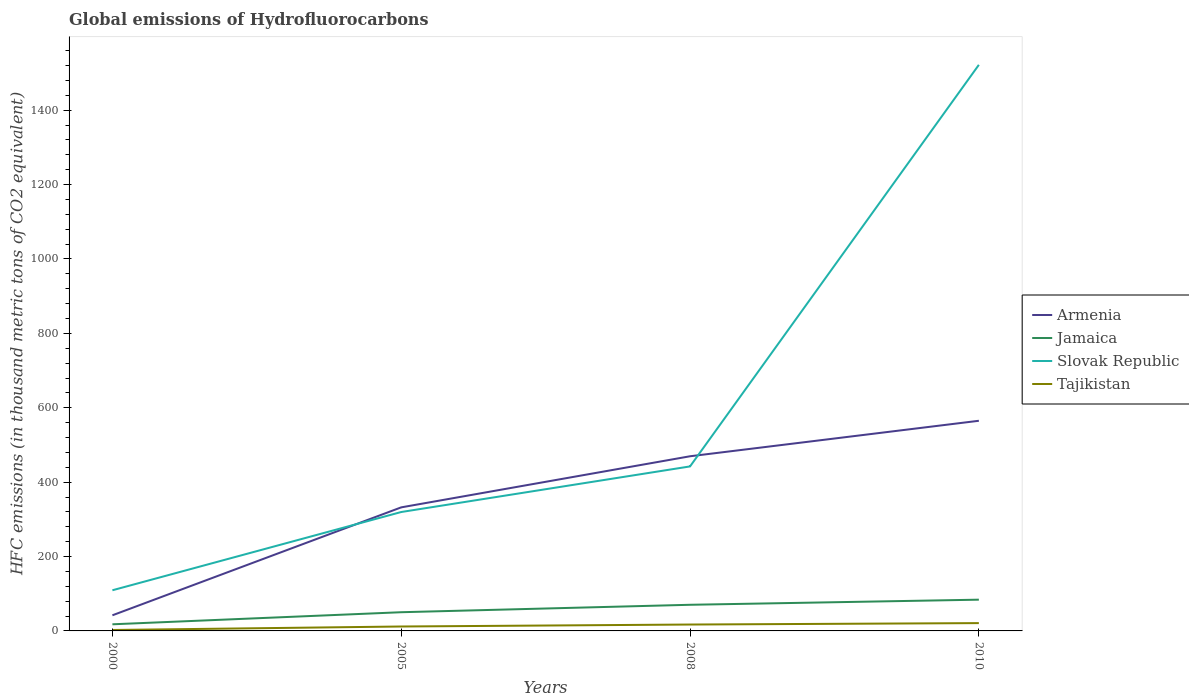How many different coloured lines are there?
Your response must be concise. 4. Does the line corresponding to Armenia intersect with the line corresponding to Jamaica?
Offer a very short reply. No. In which year was the global emissions of Hydrofluorocarbons in Armenia maximum?
Your answer should be compact. 2000. What is the total global emissions of Hydrofluorocarbons in Slovak Republic in the graph?
Ensure brevity in your answer.  -1412.7. What is the difference between the highest and the second highest global emissions of Hydrofluorocarbons in Slovak Republic?
Offer a terse response. 1412.7. What is the difference between the highest and the lowest global emissions of Hydrofluorocarbons in Jamaica?
Provide a succinct answer. 2. Is the global emissions of Hydrofluorocarbons in Armenia strictly greater than the global emissions of Hydrofluorocarbons in Jamaica over the years?
Make the answer very short. No. How many lines are there?
Make the answer very short. 4. How many years are there in the graph?
Your answer should be very brief. 4. Are the values on the major ticks of Y-axis written in scientific E-notation?
Make the answer very short. No. Does the graph contain any zero values?
Provide a short and direct response. No. What is the title of the graph?
Keep it short and to the point. Global emissions of Hydrofluorocarbons. What is the label or title of the X-axis?
Offer a terse response. Years. What is the label or title of the Y-axis?
Give a very brief answer. HFC emissions (in thousand metric tons of CO2 equivalent). What is the HFC emissions (in thousand metric tons of CO2 equivalent) in Armenia in 2000?
Give a very brief answer. 42. What is the HFC emissions (in thousand metric tons of CO2 equivalent) of Slovak Republic in 2000?
Offer a very short reply. 109.3. What is the HFC emissions (in thousand metric tons of CO2 equivalent) of Tajikistan in 2000?
Offer a very short reply. 2.5. What is the HFC emissions (in thousand metric tons of CO2 equivalent) in Armenia in 2005?
Offer a very short reply. 332.2. What is the HFC emissions (in thousand metric tons of CO2 equivalent) in Jamaica in 2005?
Give a very brief answer. 50.3. What is the HFC emissions (in thousand metric tons of CO2 equivalent) of Slovak Republic in 2005?
Your answer should be very brief. 319.7. What is the HFC emissions (in thousand metric tons of CO2 equivalent) in Armenia in 2008?
Offer a very short reply. 469.6. What is the HFC emissions (in thousand metric tons of CO2 equivalent) in Jamaica in 2008?
Ensure brevity in your answer.  70.3. What is the HFC emissions (in thousand metric tons of CO2 equivalent) in Slovak Republic in 2008?
Offer a terse response. 442.3. What is the HFC emissions (in thousand metric tons of CO2 equivalent) of Tajikistan in 2008?
Give a very brief answer. 17.2. What is the HFC emissions (in thousand metric tons of CO2 equivalent) in Armenia in 2010?
Offer a very short reply. 565. What is the HFC emissions (in thousand metric tons of CO2 equivalent) in Jamaica in 2010?
Ensure brevity in your answer.  84. What is the HFC emissions (in thousand metric tons of CO2 equivalent) in Slovak Republic in 2010?
Keep it short and to the point. 1522. Across all years, what is the maximum HFC emissions (in thousand metric tons of CO2 equivalent) of Armenia?
Your answer should be compact. 565. Across all years, what is the maximum HFC emissions (in thousand metric tons of CO2 equivalent) of Slovak Republic?
Keep it short and to the point. 1522. Across all years, what is the maximum HFC emissions (in thousand metric tons of CO2 equivalent) in Tajikistan?
Your answer should be compact. 21. Across all years, what is the minimum HFC emissions (in thousand metric tons of CO2 equivalent) in Armenia?
Keep it short and to the point. 42. Across all years, what is the minimum HFC emissions (in thousand metric tons of CO2 equivalent) of Jamaica?
Provide a short and direct response. 17.8. Across all years, what is the minimum HFC emissions (in thousand metric tons of CO2 equivalent) in Slovak Republic?
Keep it short and to the point. 109.3. What is the total HFC emissions (in thousand metric tons of CO2 equivalent) in Armenia in the graph?
Ensure brevity in your answer.  1408.8. What is the total HFC emissions (in thousand metric tons of CO2 equivalent) of Jamaica in the graph?
Offer a terse response. 222.4. What is the total HFC emissions (in thousand metric tons of CO2 equivalent) in Slovak Republic in the graph?
Keep it short and to the point. 2393.3. What is the total HFC emissions (in thousand metric tons of CO2 equivalent) in Tajikistan in the graph?
Give a very brief answer. 52.6. What is the difference between the HFC emissions (in thousand metric tons of CO2 equivalent) in Armenia in 2000 and that in 2005?
Make the answer very short. -290.2. What is the difference between the HFC emissions (in thousand metric tons of CO2 equivalent) in Jamaica in 2000 and that in 2005?
Your answer should be compact. -32.5. What is the difference between the HFC emissions (in thousand metric tons of CO2 equivalent) of Slovak Republic in 2000 and that in 2005?
Give a very brief answer. -210.4. What is the difference between the HFC emissions (in thousand metric tons of CO2 equivalent) of Tajikistan in 2000 and that in 2005?
Give a very brief answer. -9.4. What is the difference between the HFC emissions (in thousand metric tons of CO2 equivalent) in Armenia in 2000 and that in 2008?
Ensure brevity in your answer.  -427.6. What is the difference between the HFC emissions (in thousand metric tons of CO2 equivalent) of Jamaica in 2000 and that in 2008?
Make the answer very short. -52.5. What is the difference between the HFC emissions (in thousand metric tons of CO2 equivalent) in Slovak Republic in 2000 and that in 2008?
Offer a very short reply. -333. What is the difference between the HFC emissions (in thousand metric tons of CO2 equivalent) of Tajikistan in 2000 and that in 2008?
Make the answer very short. -14.7. What is the difference between the HFC emissions (in thousand metric tons of CO2 equivalent) in Armenia in 2000 and that in 2010?
Offer a very short reply. -523. What is the difference between the HFC emissions (in thousand metric tons of CO2 equivalent) in Jamaica in 2000 and that in 2010?
Your answer should be compact. -66.2. What is the difference between the HFC emissions (in thousand metric tons of CO2 equivalent) of Slovak Republic in 2000 and that in 2010?
Your answer should be very brief. -1412.7. What is the difference between the HFC emissions (in thousand metric tons of CO2 equivalent) of Tajikistan in 2000 and that in 2010?
Give a very brief answer. -18.5. What is the difference between the HFC emissions (in thousand metric tons of CO2 equivalent) of Armenia in 2005 and that in 2008?
Your response must be concise. -137.4. What is the difference between the HFC emissions (in thousand metric tons of CO2 equivalent) of Jamaica in 2005 and that in 2008?
Provide a short and direct response. -20. What is the difference between the HFC emissions (in thousand metric tons of CO2 equivalent) of Slovak Republic in 2005 and that in 2008?
Keep it short and to the point. -122.6. What is the difference between the HFC emissions (in thousand metric tons of CO2 equivalent) of Armenia in 2005 and that in 2010?
Keep it short and to the point. -232.8. What is the difference between the HFC emissions (in thousand metric tons of CO2 equivalent) of Jamaica in 2005 and that in 2010?
Provide a short and direct response. -33.7. What is the difference between the HFC emissions (in thousand metric tons of CO2 equivalent) in Slovak Republic in 2005 and that in 2010?
Ensure brevity in your answer.  -1202.3. What is the difference between the HFC emissions (in thousand metric tons of CO2 equivalent) of Tajikistan in 2005 and that in 2010?
Ensure brevity in your answer.  -9.1. What is the difference between the HFC emissions (in thousand metric tons of CO2 equivalent) of Armenia in 2008 and that in 2010?
Your answer should be very brief. -95.4. What is the difference between the HFC emissions (in thousand metric tons of CO2 equivalent) of Jamaica in 2008 and that in 2010?
Give a very brief answer. -13.7. What is the difference between the HFC emissions (in thousand metric tons of CO2 equivalent) in Slovak Republic in 2008 and that in 2010?
Your response must be concise. -1079.7. What is the difference between the HFC emissions (in thousand metric tons of CO2 equivalent) of Tajikistan in 2008 and that in 2010?
Your answer should be compact. -3.8. What is the difference between the HFC emissions (in thousand metric tons of CO2 equivalent) of Armenia in 2000 and the HFC emissions (in thousand metric tons of CO2 equivalent) of Slovak Republic in 2005?
Make the answer very short. -277.7. What is the difference between the HFC emissions (in thousand metric tons of CO2 equivalent) in Armenia in 2000 and the HFC emissions (in thousand metric tons of CO2 equivalent) in Tajikistan in 2005?
Offer a terse response. 30.1. What is the difference between the HFC emissions (in thousand metric tons of CO2 equivalent) in Jamaica in 2000 and the HFC emissions (in thousand metric tons of CO2 equivalent) in Slovak Republic in 2005?
Your response must be concise. -301.9. What is the difference between the HFC emissions (in thousand metric tons of CO2 equivalent) in Slovak Republic in 2000 and the HFC emissions (in thousand metric tons of CO2 equivalent) in Tajikistan in 2005?
Give a very brief answer. 97.4. What is the difference between the HFC emissions (in thousand metric tons of CO2 equivalent) in Armenia in 2000 and the HFC emissions (in thousand metric tons of CO2 equivalent) in Jamaica in 2008?
Your answer should be compact. -28.3. What is the difference between the HFC emissions (in thousand metric tons of CO2 equivalent) of Armenia in 2000 and the HFC emissions (in thousand metric tons of CO2 equivalent) of Slovak Republic in 2008?
Ensure brevity in your answer.  -400.3. What is the difference between the HFC emissions (in thousand metric tons of CO2 equivalent) of Armenia in 2000 and the HFC emissions (in thousand metric tons of CO2 equivalent) of Tajikistan in 2008?
Offer a very short reply. 24.8. What is the difference between the HFC emissions (in thousand metric tons of CO2 equivalent) in Jamaica in 2000 and the HFC emissions (in thousand metric tons of CO2 equivalent) in Slovak Republic in 2008?
Your answer should be very brief. -424.5. What is the difference between the HFC emissions (in thousand metric tons of CO2 equivalent) in Jamaica in 2000 and the HFC emissions (in thousand metric tons of CO2 equivalent) in Tajikistan in 2008?
Your answer should be very brief. 0.6. What is the difference between the HFC emissions (in thousand metric tons of CO2 equivalent) of Slovak Republic in 2000 and the HFC emissions (in thousand metric tons of CO2 equivalent) of Tajikistan in 2008?
Your answer should be very brief. 92.1. What is the difference between the HFC emissions (in thousand metric tons of CO2 equivalent) in Armenia in 2000 and the HFC emissions (in thousand metric tons of CO2 equivalent) in Jamaica in 2010?
Offer a very short reply. -42. What is the difference between the HFC emissions (in thousand metric tons of CO2 equivalent) of Armenia in 2000 and the HFC emissions (in thousand metric tons of CO2 equivalent) of Slovak Republic in 2010?
Give a very brief answer. -1480. What is the difference between the HFC emissions (in thousand metric tons of CO2 equivalent) in Armenia in 2000 and the HFC emissions (in thousand metric tons of CO2 equivalent) in Tajikistan in 2010?
Make the answer very short. 21. What is the difference between the HFC emissions (in thousand metric tons of CO2 equivalent) in Jamaica in 2000 and the HFC emissions (in thousand metric tons of CO2 equivalent) in Slovak Republic in 2010?
Your answer should be very brief. -1504.2. What is the difference between the HFC emissions (in thousand metric tons of CO2 equivalent) in Jamaica in 2000 and the HFC emissions (in thousand metric tons of CO2 equivalent) in Tajikistan in 2010?
Make the answer very short. -3.2. What is the difference between the HFC emissions (in thousand metric tons of CO2 equivalent) of Slovak Republic in 2000 and the HFC emissions (in thousand metric tons of CO2 equivalent) of Tajikistan in 2010?
Your answer should be compact. 88.3. What is the difference between the HFC emissions (in thousand metric tons of CO2 equivalent) of Armenia in 2005 and the HFC emissions (in thousand metric tons of CO2 equivalent) of Jamaica in 2008?
Your answer should be very brief. 261.9. What is the difference between the HFC emissions (in thousand metric tons of CO2 equivalent) in Armenia in 2005 and the HFC emissions (in thousand metric tons of CO2 equivalent) in Slovak Republic in 2008?
Your answer should be very brief. -110.1. What is the difference between the HFC emissions (in thousand metric tons of CO2 equivalent) of Armenia in 2005 and the HFC emissions (in thousand metric tons of CO2 equivalent) of Tajikistan in 2008?
Your answer should be very brief. 315. What is the difference between the HFC emissions (in thousand metric tons of CO2 equivalent) of Jamaica in 2005 and the HFC emissions (in thousand metric tons of CO2 equivalent) of Slovak Republic in 2008?
Offer a very short reply. -392. What is the difference between the HFC emissions (in thousand metric tons of CO2 equivalent) of Jamaica in 2005 and the HFC emissions (in thousand metric tons of CO2 equivalent) of Tajikistan in 2008?
Provide a succinct answer. 33.1. What is the difference between the HFC emissions (in thousand metric tons of CO2 equivalent) in Slovak Republic in 2005 and the HFC emissions (in thousand metric tons of CO2 equivalent) in Tajikistan in 2008?
Give a very brief answer. 302.5. What is the difference between the HFC emissions (in thousand metric tons of CO2 equivalent) in Armenia in 2005 and the HFC emissions (in thousand metric tons of CO2 equivalent) in Jamaica in 2010?
Provide a short and direct response. 248.2. What is the difference between the HFC emissions (in thousand metric tons of CO2 equivalent) of Armenia in 2005 and the HFC emissions (in thousand metric tons of CO2 equivalent) of Slovak Republic in 2010?
Keep it short and to the point. -1189.8. What is the difference between the HFC emissions (in thousand metric tons of CO2 equivalent) of Armenia in 2005 and the HFC emissions (in thousand metric tons of CO2 equivalent) of Tajikistan in 2010?
Provide a succinct answer. 311.2. What is the difference between the HFC emissions (in thousand metric tons of CO2 equivalent) of Jamaica in 2005 and the HFC emissions (in thousand metric tons of CO2 equivalent) of Slovak Republic in 2010?
Make the answer very short. -1471.7. What is the difference between the HFC emissions (in thousand metric tons of CO2 equivalent) in Jamaica in 2005 and the HFC emissions (in thousand metric tons of CO2 equivalent) in Tajikistan in 2010?
Your answer should be compact. 29.3. What is the difference between the HFC emissions (in thousand metric tons of CO2 equivalent) in Slovak Republic in 2005 and the HFC emissions (in thousand metric tons of CO2 equivalent) in Tajikistan in 2010?
Give a very brief answer. 298.7. What is the difference between the HFC emissions (in thousand metric tons of CO2 equivalent) in Armenia in 2008 and the HFC emissions (in thousand metric tons of CO2 equivalent) in Jamaica in 2010?
Your response must be concise. 385.6. What is the difference between the HFC emissions (in thousand metric tons of CO2 equivalent) of Armenia in 2008 and the HFC emissions (in thousand metric tons of CO2 equivalent) of Slovak Republic in 2010?
Offer a very short reply. -1052.4. What is the difference between the HFC emissions (in thousand metric tons of CO2 equivalent) in Armenia in 2008 and the HFC emissions (in thousand metric tons of CO2 equivalent) in Tajikistan in 2010?
Provide a short and direct response. 448.6. What is the difference between the HFC emissions (in thousand metric tons of CO2 equivalent) in Jamaica in 2008 and the HFC emissions (in thousand metric tons of CO2 equivalent) in Slovak Republic in 2010?
Your answer should be compact. -1451.7. What is the difference between the HFC emissions (in thousand metric tons of CO2 equivalent) in Jamaica in 2008 and the HFC emissions (in thousand metric tons of CO2 equivalent) in Tajikistan in 2010?
Offer a terse response. 49.3. What is the difference between the HFC emissions (in thousand metric tons of CO2 equivalent) in Slovak Republic in 2008 and the HFC emissions (in thousand metric tons of CO2 equivalent) in Tajikistan in 2010?
Ensure brevity in your answer.  421.3. What is the average HFC emissions (in thousand metric tons of CO2 equivalent) of Armenia per year?
Your response must be concise. 352.2. What is the average HFC emissions (in thousand metric tons of CO2 equivalent) of Jamaica per year?
Your answer should be compact. 55.6. What is the average HFC emissions (in thousand metric tons of CO2 equivalent) in Slovak Republic per year?
Provide a short and direct response. 598.33. What is the average HFC emissions (in thousand metric tons of CO2 equivalent) of Tajikistan per year?
Provide a succinct answer. 13.15. In the year 2000, what is the difference between the HFC emissions (in thousand metric tons of CO2 equivalent) of Armenia and HFC emissions (in thousand metric tons of CO2 equivalent) of Jamaica?
Provide a short and direct response. 24.2. In the year 2000, what is the difference between the HFC emissions (in thousand metric tons of CO2 equivalent) of Armenia and HFC emissions (in thousand metric tons of CO2 equivalent) of Slovak Republic?
Offer a terse response. -67.3. In the year 2000, what is the difference between the HFC emissions (in thousand metric tons of CO2 equivalent) in Armenia and HFC emissions (in thousand metric tons of CO2 equivalent) in Tajikistan?
Provide a succinct answer. 39.5. In the year 2000, what is the difference between the HFC emissions (in thousand metric tons of CO2 equivalent) in Jamaica and HFC emissions (in thousand metric tons of CO2 equivalent) in Slovak Republic?
Keep it short and to the point. -91.5. In the year 2000, what is the difference between the HFC emissions (in thousand metric tons of CO2 equivalent) of Jamaica and HFC emissions (in thousand metric tons of CO2 equivalent) of Tajikistan?
Provide a succinct answer. 15.3. In the year 2000, what is the difference between the HFC emissions (in thousand metric tons of CO2 equivalent) of Slovak Republic and HFC emissions (in thousand metric tons of CO2 equivalent) of Tajikistan?
Provide a short and direct response. 106.8. In the year 2005, what is the difference between the HFC emissions (in thousand metric tons of CO2 equivalent) in Armenia and HFC emissions (in thousand metric tons of CO2 equivalent) in Jamaica?
Your response must be concise. 281.9. In the year 2005, what is the difference between the HFC emissions (in thousand metric tons of CO2 equivalent) in Armenia and HFC emissions (in thousand metric tons of CO2 equivalent) in Tajikistan?
Your answer should be very brief. 320.3. In the year 2005, what is the difference between the HFC emissions (in thousand metric tons of CO2 equivalent) in Jamaica and HFC emissions (in thousand metric tons of CO2 equivalent) in Slovak Republic?
Keep it short and to the point. -269.4. In the year 2005, what is the difference between the HFC emissions (in thousand metric tons of CO2 equivalent) in Jamaica and HFC emissions (in thousand metric tons of CO2 equivalent) in Tajikistan?
Provide a succinct answer. 38.4. In the year 2005, what is the difference between the HFC emissions (in thousand metric tons of CO2 equivalent) in Slovak Republic and HFC emissions (in thousand metric tons of CO2 equivalent) in Tajikistan?
Your answer should be compact. 307.8. In the year 2008, what is the difference between the HFC emissions (in thousand metric tons of CO2 equivalent) of Armenia and HFC emissions (in thousand metric tons of CO2 equivalent) of Jamaica?
Your answer should be very brief. 399.3. In the year 2008, what is the difference between the HFC emissions (in thousand metric tons of CO2 equivalent) in Armenia and HFC emissions (in thousand metric tons of CO2 equivalent) in Slovak Republic?
Keep it short and to the point. 27.3. In the year 2008, what is the difference between the HFC emissions (in thousand metric tons of CO2 equivalent) of Armenia and HFC emissions (in thousand metric tons of CO2 equivalent) of Tajikistan?
Offer a very short reply. 452.4. In the year 2008, what is the difference between the HFC emissions (in thousand metric tons of CO2 equivalent) of Jamaica and HFC emissions (in thousand metric tons of CO2 equivalent) of Slovak Republic?
Your response must be concise. -372. In the year 2008, what is the difference between the HFC emissions (in thousand metric tons of CO2 equivalent) in Jamaica and HFC emissions (in thousand metric tons of CO2 equivalent) in Tajikistan?
Make the answer very short. 53.1. In the year 2008, what is the difference between the HFC emissions (in thousand metric tons of CO2 equivalent) in Slovak Republic and HFC emissions (in thousand metric tons of CO2 equivalent) in Tajikistan?
Your answer should be very brief. 425.1. In the year 2010, what is the difference between the HFC emissions (in thousand metric tons of CO2 equivalent) of Armenia and HFC emissions (in thousand metric tons of CO2 equivalent) of Jamaica?
Your response must be concise. 481. In the year 2010, what is the difference between the HFC emissions (in thousand metric tons of CO2 equivalent) of Armenia and HFC emissions (in thousand metric tons of CO2 equivalent) of Slovak Republic?
Give a very brief answer. -957. In the year 2010, what is the difference between the HFC emissions (in thousand metric tons of CO2 equivalent) of Armenia and HFC emissions (in thousand metric tons of CO2 equivalent) of Tajikistan?
Offer a terse response. 544. In the year 2010, what is the difference between the HFC emissions (in thousand metric tons of CO2 equivalent) of Jamaica and HFC emissions (in thousand metric tons of CO2 equivalent) of Slovak Republic?
Your answer should be very brief. -1438. In the year 2010, what is the difference between the HFC emissions (in thousand metric tons of CO2 equivalent) in Jamaica and HFC emissions (in thousand metric tons of CO2 equivalent) in Tajikistan?
Ensure brevity in your answer.  63. In the year 2010, what is the difference between the HFC emissions (in thousand metric tons of CO2 equivalent) of Slovak Republic and HFC emissions (in thousand metric tons of CO2 equivalent) of Tajikistan?
Ensure brevity in your answer.  1501. What is the ratio of the HFC emissions (in thousand metric tons of CO2 equivalent) in Armenia in 2000 to that in 2005?
Your answer should be very brief. 0.13. What is the ratio of the HFC emissions (in thousand metric tons of CO2 equivalent) in Jamaica in 2000 to that in 2005?
Provide a succinct answer. 0.35. What is the ratio of the HFC emissions (in thousand metric tons of CO2 equivalent) in Slovak Republic in 2000 to that in 2005?
Keep it short and to the point. 0.34. What is the ratio of the HFC emissions (in thousand metric tons of CO2 equivalent) of Tajikistan in 2000 to that in 2005?
Your answer should be compact. 0.21. What is the ratio of the HFC emissions (in thousand metric tons of CO2 equivalent) in Armenia in 2000 to that in 2008?
Keep it short and to the point. 0.09. What is the ratio of the HFC emissions (in thousand metric tons of CO2 equivalent) in Jamaica in 2000 to that in 2008?
Ensure brevity in your answer.  0.25. What is the ratio of the HFC emissions (in thousand metric tons of CO2 equivalent) in Slovak Republic in 2000 to that in 2008?
Provide a short and direct response. 0.25. What is the ratio of the HFC emissions (in thousand metric tons of CO2 equivalent) in Tajikistan in 2000 to that in 2008?
Your answer should be compact. 0.15. What is the ratio of the HFC emissions (in thousand metric tons of CO2 equivalent) of Armenia in 2000 to that in 2010?
Make the answer very short. 0.07. What is the ratio of the HFC emissions (in thousand metric tons of CO2 equivalent) in Jamaica in 2000 to that in 2010?
Provide a succinct answer. 0.21. What is the ratio of the HFC emissions (in thousand metric tons of CO2 equivalent) in Slovak Republic in 2000 to that in 2010?
Ensure brevity in your answer.  0.07. What is the ratio of the HFC emissions (in thousand metric tons of CO2 equivalent) of Tajikistan in 2000 to that in 2010?
Your answer should be compact. 0.12. What is the ratio of the HFC emissions (in thousand metric tons of CO2 equivalent) in Armenia in 2005 to that in 2008?
Offer a very short reply. 0.71. What is the ratio of the HFC emissions (in thousand metric tons of CO2 equivalent) of Jamaica in 2005 to that in 2008?
Offer a terse response. 0.72. What is the ratio of the HFC emissions (in thousand metric tons of CO2 equivalent) in Slovak Republic in 2005 to that in 2008?
Your answer should be very brief. 0.72. What is the ratio of the HFC emissions (in thousand metric tons of CO2 equivalent) in Tajikistan in 2005 to that in 2008?
Give a very brief answer. 0.69. What is the ratio of the HFC emissions (in thousand metric tons of CO2 equivalent) of Armenia in 2005 to that in 2010?
Offer a very short reply. 0.59. What is the ratio of the HFC emissions (in thousand metric tons of CO2 equivalent) of Jamaica in 2005 to that in 2010?
Your response must be concise. 0.6. What is the ratio of the HFC emissions (in thousand metric tons of CO2 equivalent) in Slovak Republic in 2005 to that in 2010?
Offer a terse response. 0.21. What is the ratio of the HFC emissions (in thousand metric tons of CO2 equivalent) in Tajikistan in 2005 to that in 2010?
Make the answer very short. 0.57. What is the ratio of the HFC emissions (in thousand metric tons of CO2 equivalent) of Armenia in 2008 to that in 2010?
Provide a succinct answer. 0.83. What is the ratio of the HFC emissions (in thousand metric tons of CO2 equivalent) in Jamaica in 2008 to that in 2010?
Give a very brief answer. 0.84. What is the ratio of the HFC emissions (in thousand metric tons of CO2 equivalent) of Slovak Republic in 2008 to that in 2010?
Your answer should be very brief. 0.29. What is the ratio of the HFC emissions (in thousand metric tons of CO2 equivalent) of Tajikistan in 2008 to that in 2010?
Make the answer very short. 0.82. What is the difference between the highest and the second highest HFC emissions (in thousand metric tons of CO2 equivalent) in Armenia?
Offer a very short reply. 95.4. What is the difference between the highest and the second highest HFC emissions (in thousand metric tons of CO2 equivalent) of Jamaica?
Ensure brevity in your answer.  13.7. What is the difference between the highest and the second highest HFC emissions (in thousand metric tons of CO2 equivalent) in Slovak Republic?
Provide a succinct answer. 1079.7. What is the difference between the highest and the second highest HFC emissions (in thousand metric tons of CO2 equivalent) in Tajikistan?
Make the answer very short. 3.8. What is the difference between the highest and the lowest HFC emissions (in thousand metric tons of CO2 equivalent) in Armenia?
Make the answer very short. 523. What is the difference between the highest and the lowest HFC emissions (in thousand metric tons of CO2 equivalent) of Jamaica?
Provide a succinct answer. 66.2. What is the difference between the highest and the lowest HFC emissions (in thousand metric tons of CO2 equivalent) in Slovak Republic?
Ensure brevity in your answer.  1412.7. 